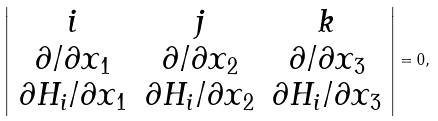Convert formula to latex. <formula><loc_0><loc_0><loc_500><loc_500>\left | \begin{array} { c c c } i & j & k \\ \partial / \partial x _ { 1 } & \partial / \partial x _ { 2 } & \partial / \partial x _ { 3 } \\ \partial H _ { i } / \partial x _ { 1 } & \partial H _ { i } / \partial x _ { 2 } & \partial H _ { i } / \partial x _ { 3 } \\ \end{array} \right | = 0 ,</formula> 